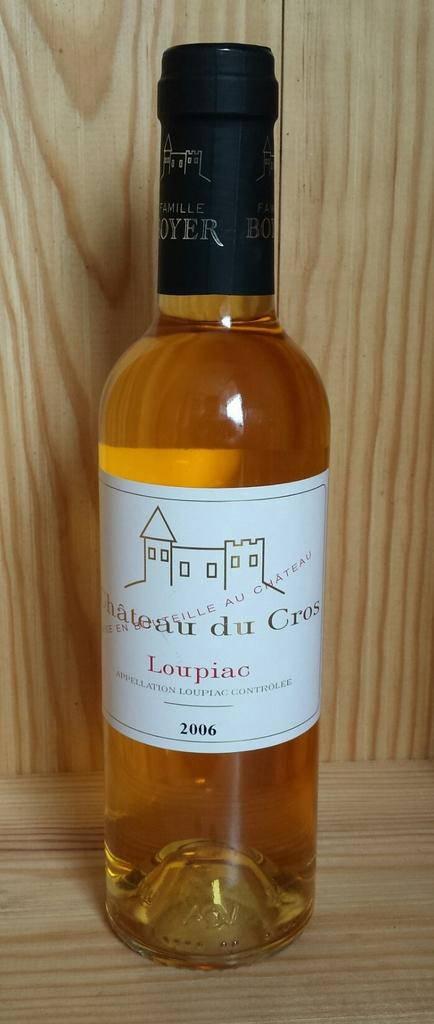<image>
Render a clear and concise summary of the photo. A bottle of Chateau du Cros wine sits on a wooden table. 